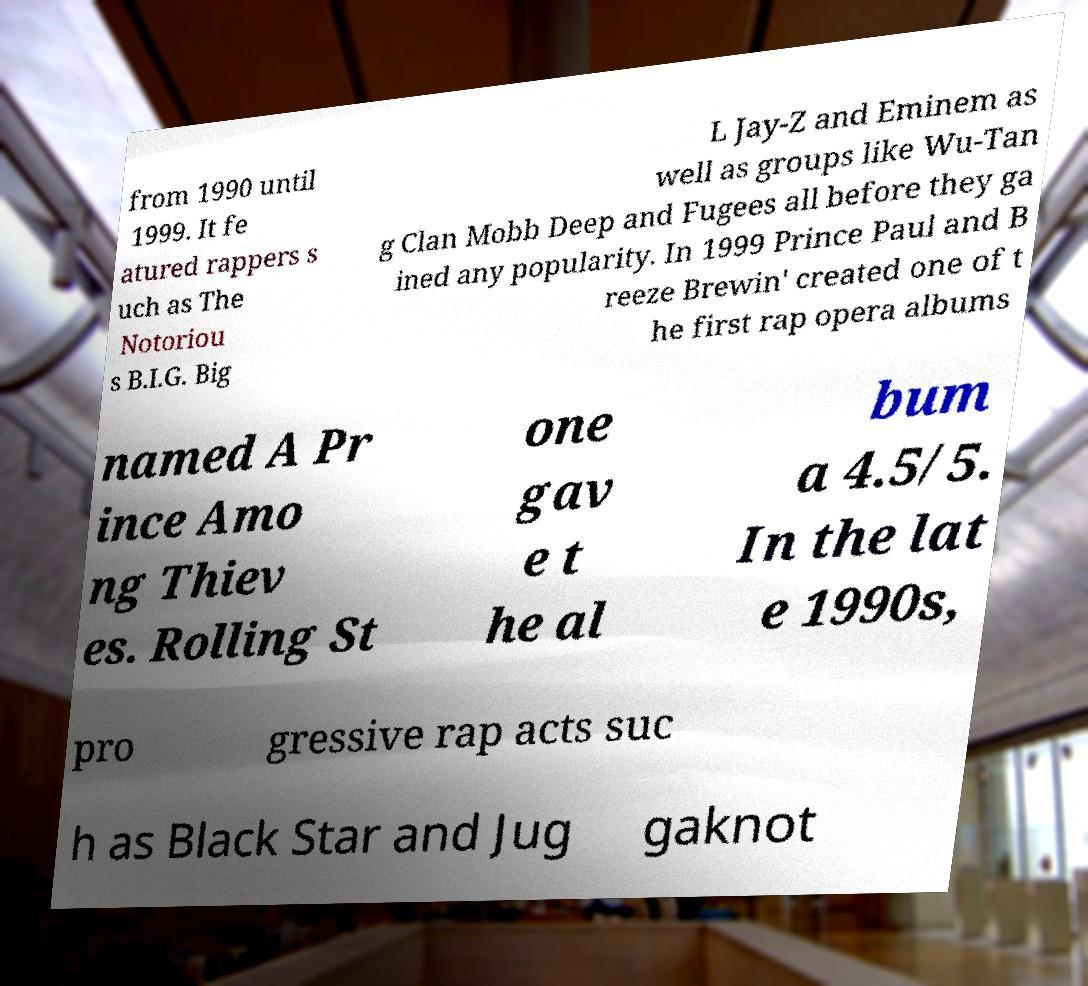Please read and relay the text visible in this image. What does it say? from 1990 until 1999. It fe atured rappers s uch as The Notoriou s B.I.G. Big L Jay-Z and Eminem as well as groups like Wu-Tan g Clan Mobb Deep and Fugees all before they ga ined any popularity. In 1999 Prince Paul and B reeze Brewin' created one of t he first rap opera albums named A Pr ince Amo ng Thiev es. Rolling St one gav e t he al bum a 4.5/5. In the lat e 1990s, pro gressive rap acts suc h as Black Star and Jug gaknot 